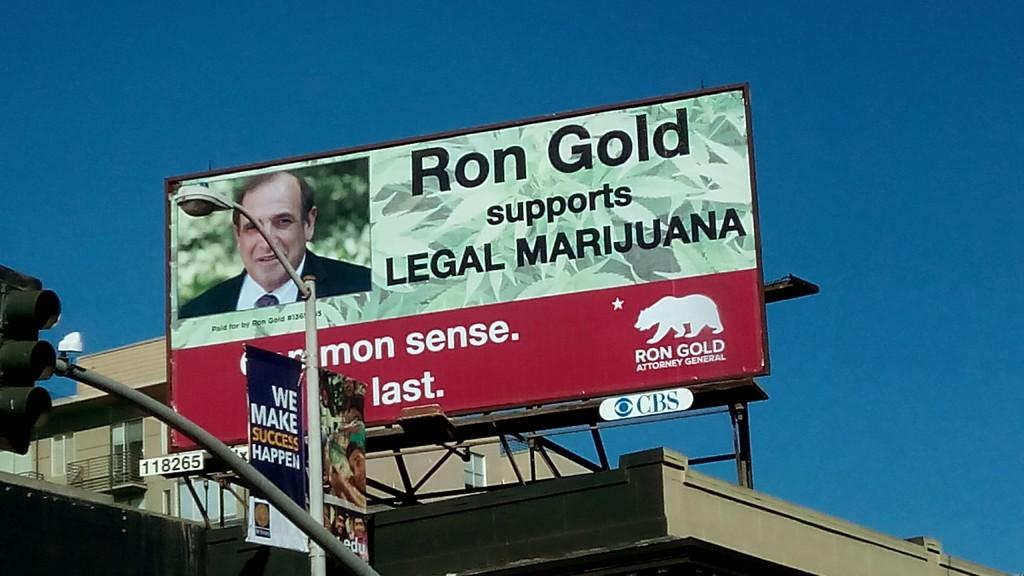<image>
Write a terse but informative summary of the picture. The ad is for the candidate Ron Gold 